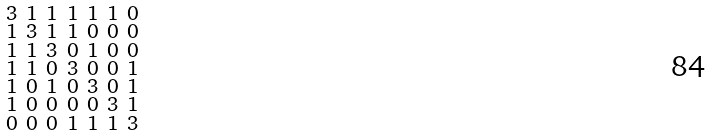Convert formula to latex. <formula><loc_0><loc_0><loc_500><loc_500>\begin{smallmatrix} 3 & 1 & 1 & 1 & 1 & 1 & 0 \\ 1 & 3 & 1 & 1 & 0 & 0 & 0 \\ 1 & 1 & 3 & 0 & 1 & 0 & 0 \\ 1 & 1 & 0 & 3 & 0 & 0 & 1 \\ 1 & 0 & 1 & 0 & 3 & 0 & 1 \\ 1 & 0 & 0 & 0 & 0 & 3 & 1 \\ 0 & 0 & 0 & 1 & 1 & 1 & 3 \end{smallmatrix}</formula> 